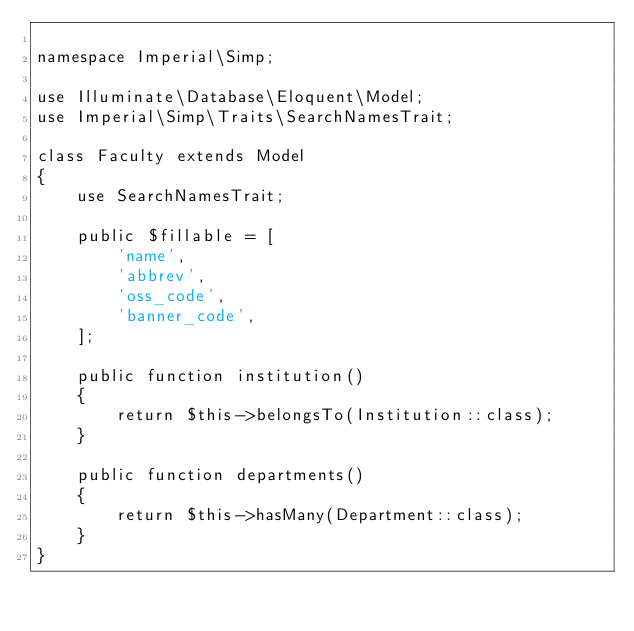<code> <loc_0><loc_0><loc_500><loc_500><_PHP_>
namespace Imperial\Simp;

use Illuminate\Database\Eloquent\Model;
use Imperial\Simp\Traits\SearchNamesTrait;

class Faculty extends Model
{
    use SearchNamesTrait;

    public $fillable = [
        'name',
        'abbrev',
        'oss_code',
        'banner_code',
    ];

    public function institution()
    {
        return $this->belongsTo(Institution::class);
    }

    public function departments()
    {
        return $this->hasMany(Department::class);
    }
}
</code> 